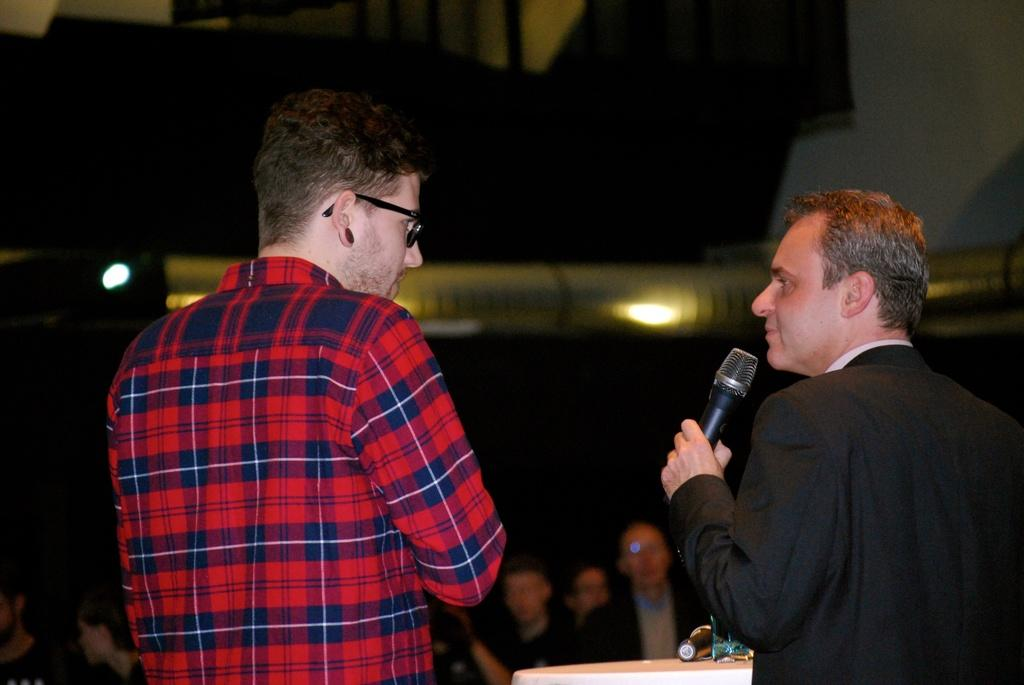How many people are in the image? There are two men in the image. What is one of the men holding in his hand? One of the men is holding a microphone in his hand. What type of polish is being applied to the microphone in the image? There is no polish present in the image, nor is there any indication that the microphone is being polished. 